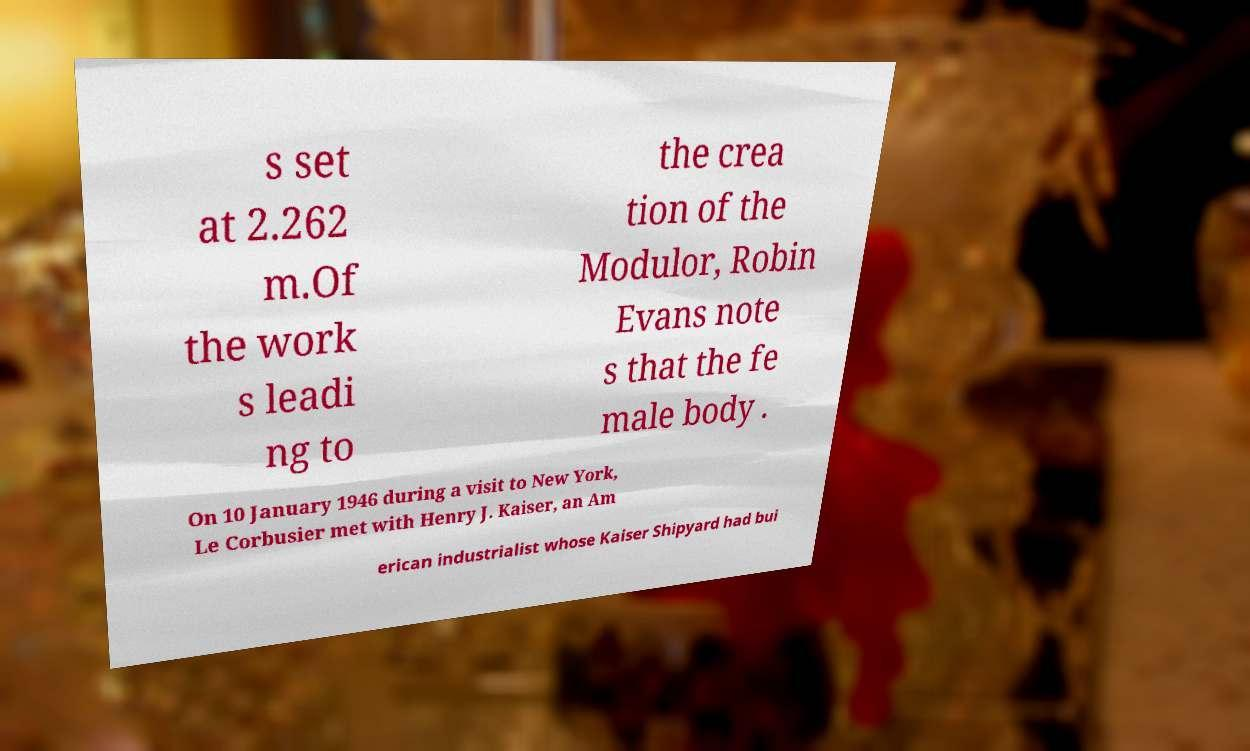For documentation purposes, I need the text within this image transcribed. Could you provide that? s set at 2.262 m.Of the work s leadi ng to the crea tion of the Modulor, Robin Evans note s that the fe male body . On 10 January 1946 during a visit to New York, Le Corbusier met with Henry J. Kaiser, an Am erican industrialist whose Kaiser Shipyard had bui 